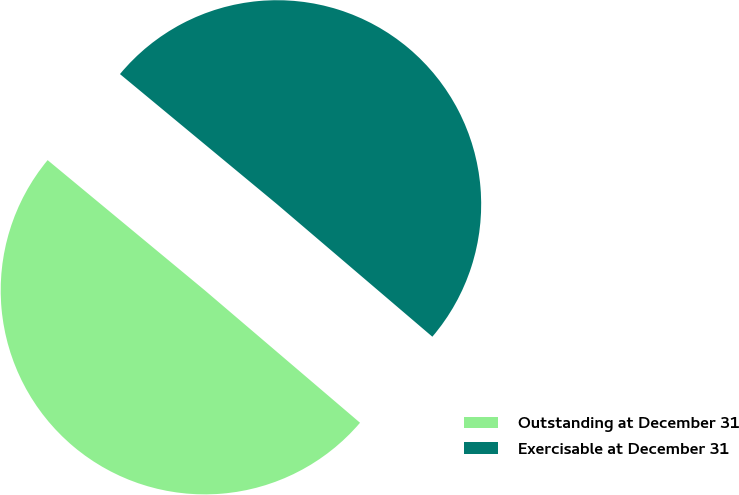Convert chart to OTSL. <chart><loc_0><loc_0><loc_500><loc_500><pie_chart><fcel>Outstanding at December 31<fcel>Exercisable at December 31<nl><fcel>49.77%<fcel>50.23%<nl></chart> 